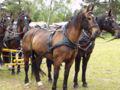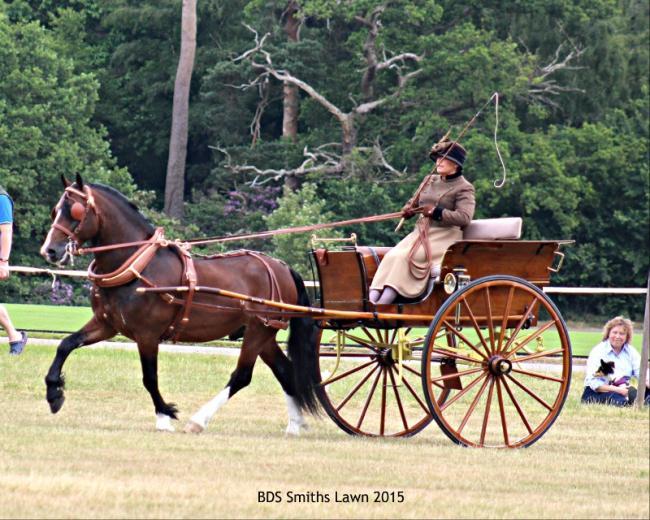The first image is the image on the left, the second image is the image on the right. Evaluate the accuracy of this statement regarding the images: "A man in a helmet is being pulled by at least one horse.". Is it true? Answer yes or no. No. The first image is the image on the left, the second image is the image on the right. Given the left and right images, does the statement "There are exactly three horses." hold true? Answer yes or no. No. 